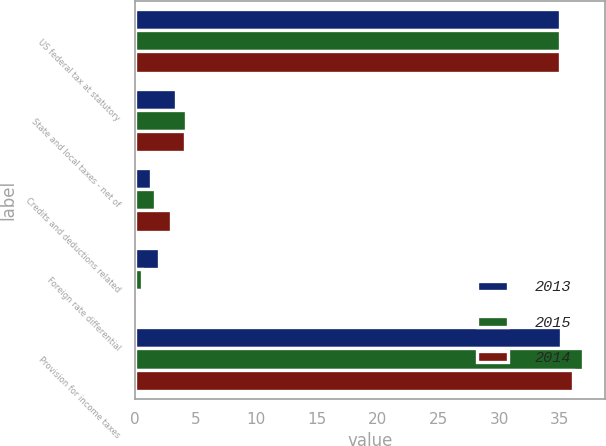Convert chart. <chart><loc_0><loc_0><loc_500><loc_500><stacked_bar_chart><ecel><fcel>US federal tax at statutory<fcel>State and local taxes - net of<fcel>Credits and deductions related<fcel>Foreign rate differential<fcel>Provision for income taxes<nl><fcel>2013<fcel>35<fcel>3.4<fcel>1.3<fcel>2<fcel>35.1<nl><fcel>2015<fcel>35<fcel>4.2<fcel>1.7<fcel>0.6<fcel>36.9<nl><fcel>2014<fcel>35<fcel>4.1<fcel>3<fcel>0.3<fcel>36.1<nl></chart> 